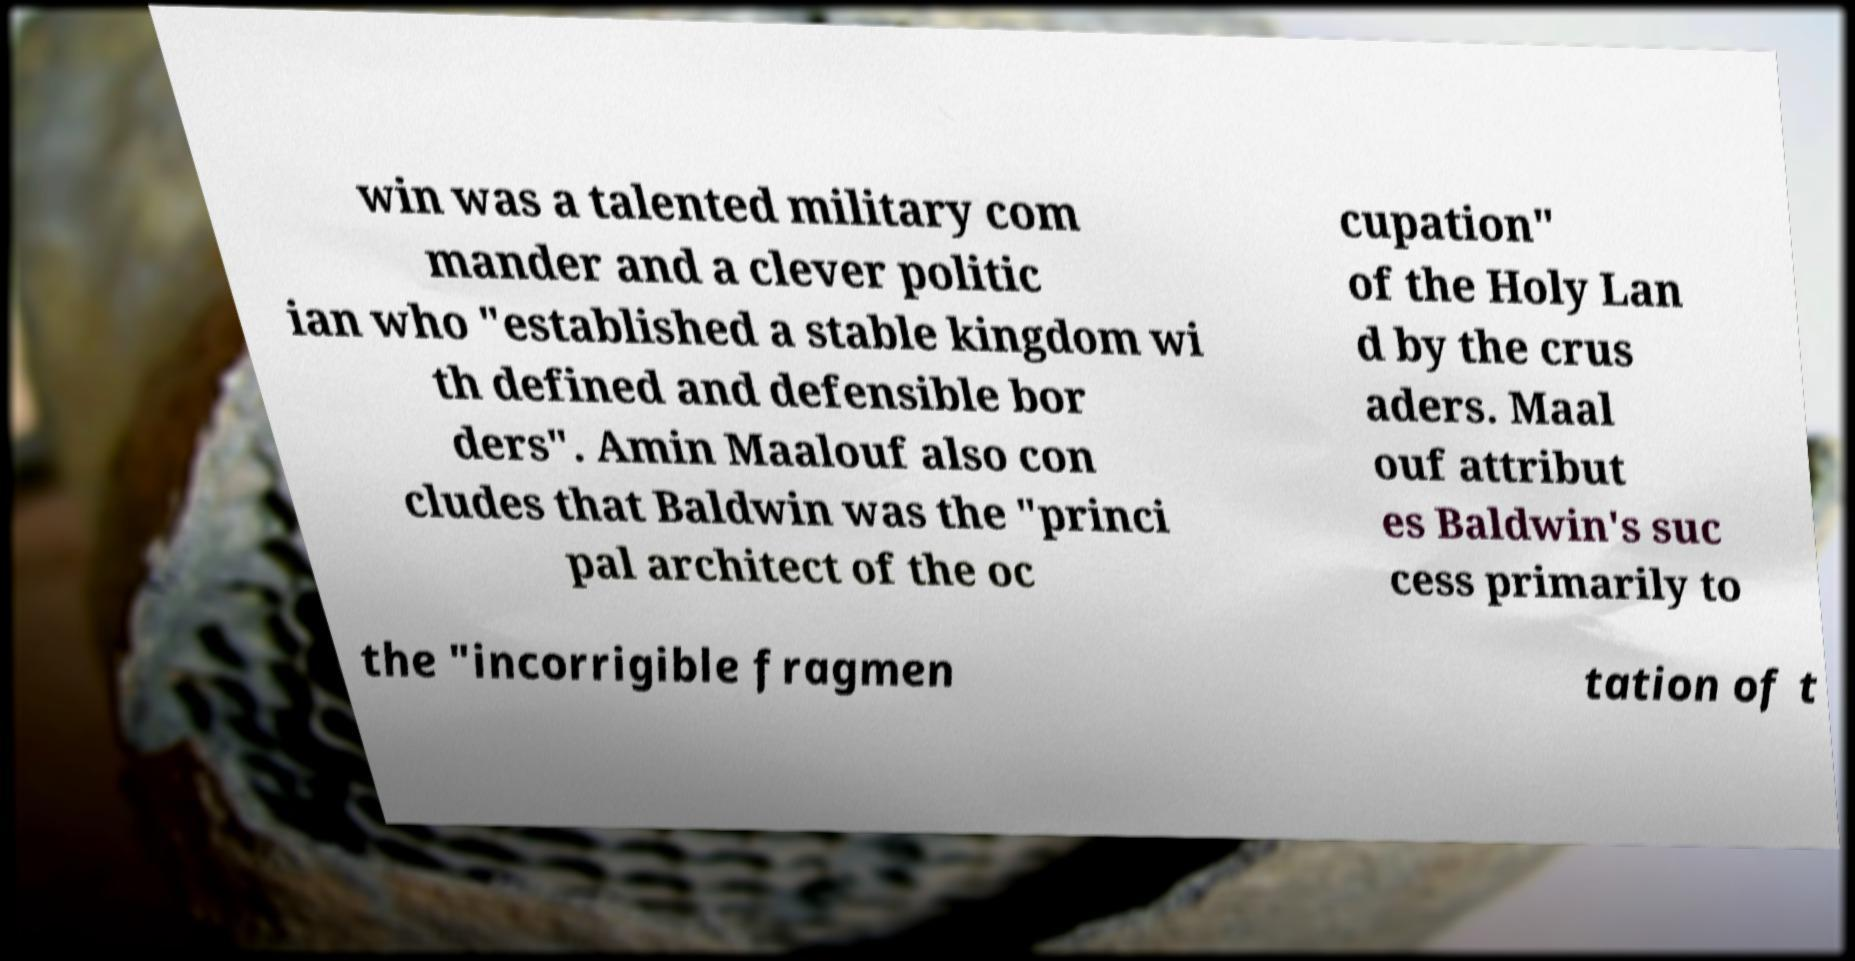I need the written content from this picture converted into text. Can you do that? win was a talented military com mander and a clever politic ian who "established a stable kingdom wi th defined and defensible bor ders". Amin Maalouf also con cludes that Baldwin was the "princi pal architect of the oc cupation" of the Holy Lan d by the crus aders. Maal ouf attribut es Baldwin's suc cess primarily to the "incorrigible fragmen tation of t 